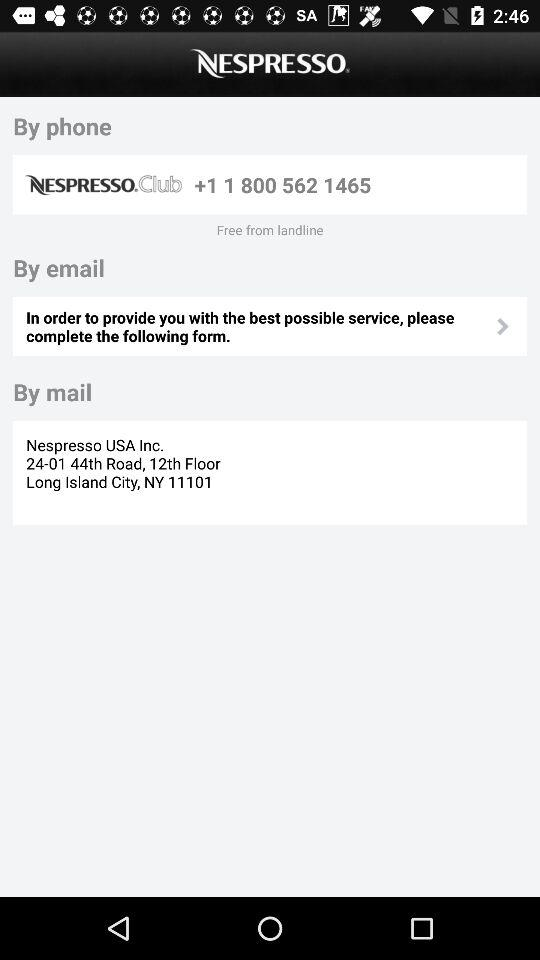How many contact methods are there?
Answer the question using a single word or phrase. 3 